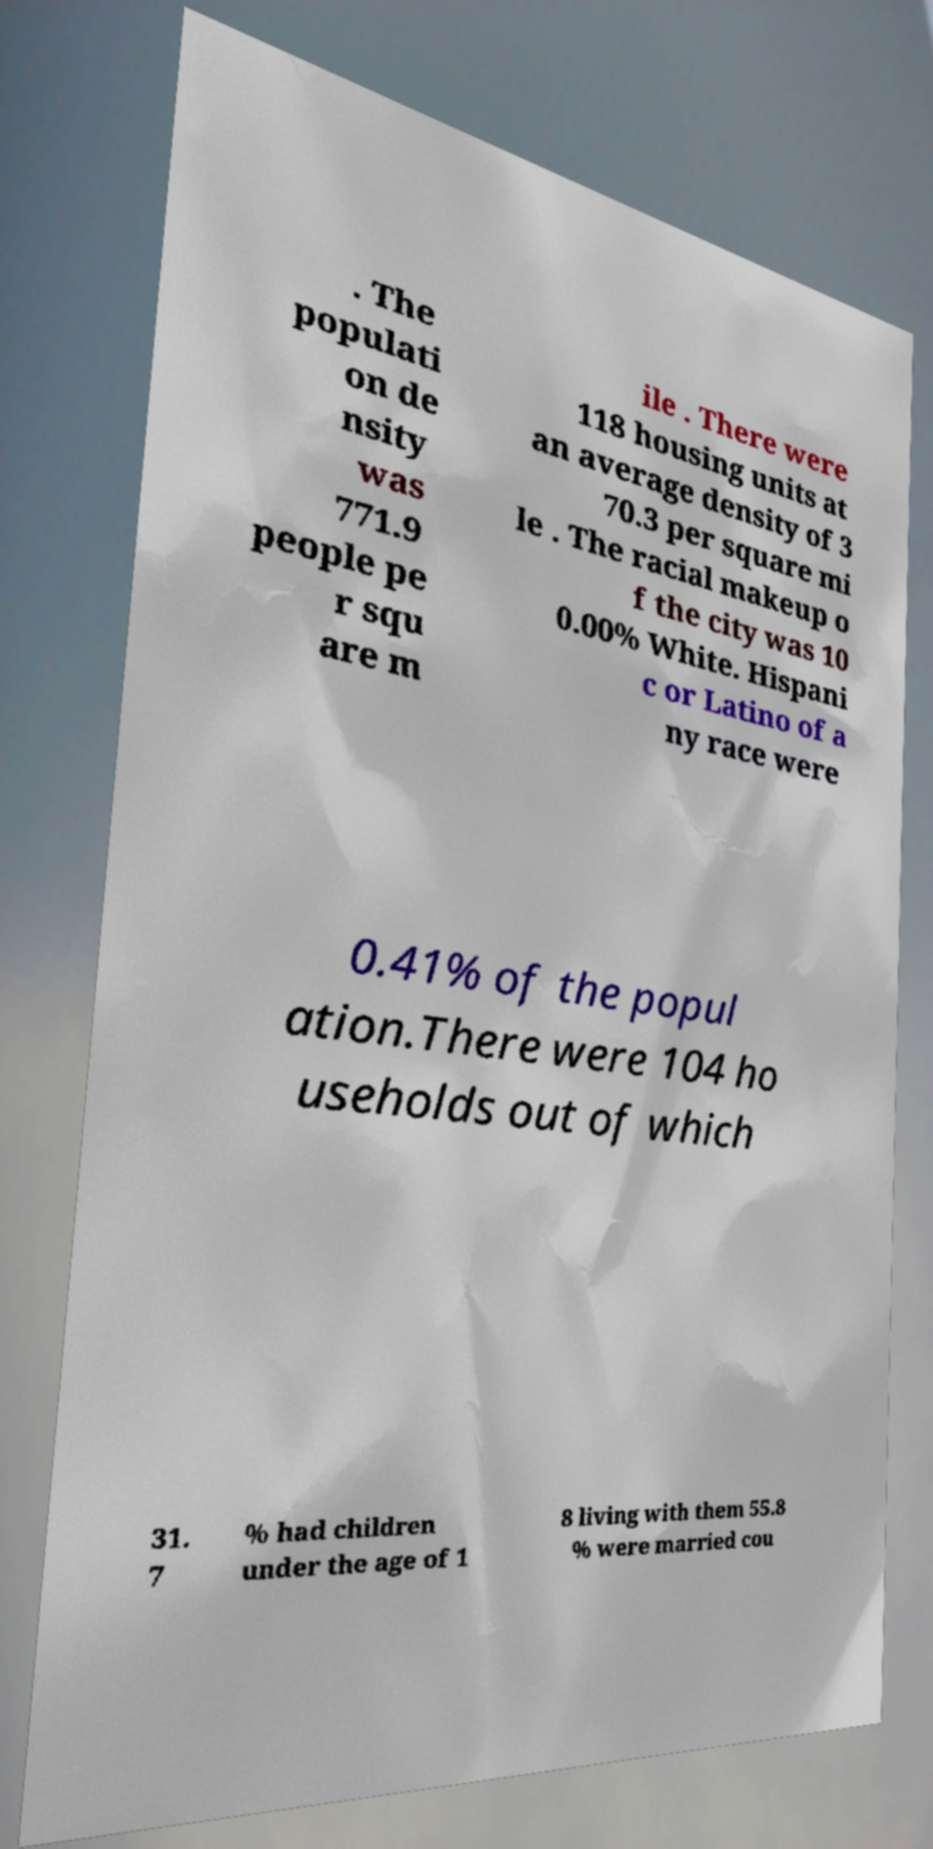Please identify and transcribe the text found in this image. . The populati on de nsity was 771.9 people pe r squ are m ile . There were 118 housing units at an average density of 3 70.3 per square mi le . The racial makeup o f the city was 10 0.00% White. Hispani c or Latino of a ny race were 0.41% of the popul ation.There were 104 ho useholds out of which 31. 7 % had children under the age of 1 8 living with them 55.8 % were married cou 